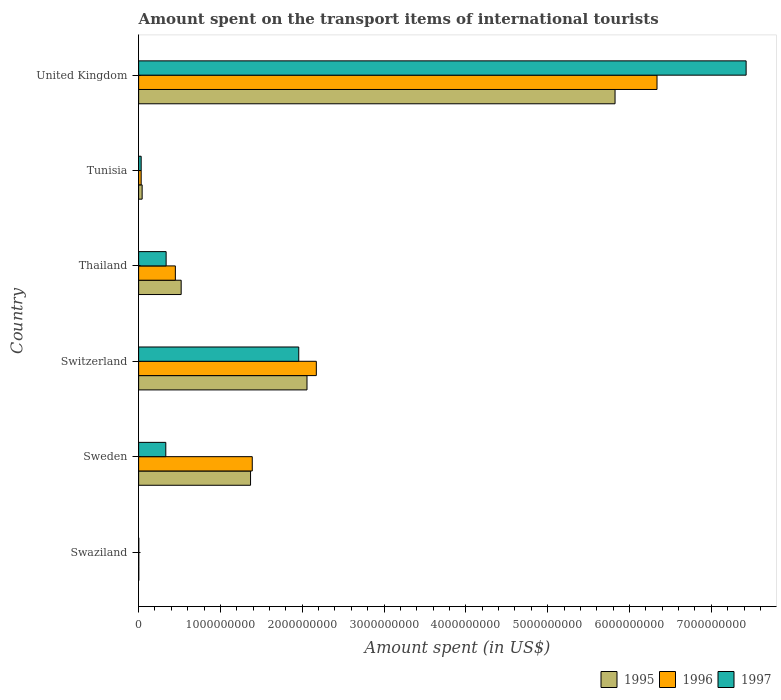How many groups of bars are there?
Give a very brief answer. 6. Are the number of bars per tick equal to the number of legend labels?
Your response must be concise. Yes. In how many cases, is the number of bars for a given country not equal to the number of legend labels?
Provide a succinct answer. 0. What is the amount spent on the transport items of international tourists in 1997 in Sweden?
Make the answer very short. 3.32e+08. Across all countries, what is the maximum amount spent on the transport items of international tourists in 1995?
Your answer should be very brief. 5.82e+09. Across all countries, what is the minimum amount spent on the transport items of international tourists in 1996?
Make the answer very short. 2.00e+06. In which country was the amount spent on the transport items of international tourists in 1996 minimum?
Make the answer very short. Swaziland. What is the total amount spent on the transport items of international tourists in 1996 in the graph?
Ensure brevity in your answer.  1.04e+1. What is the difference between the amount spent on the transport items of international tourists in 1995 in Tunisia and that in United Kingdom?
Provide a succinct answer. -5.78e+09. What is the difference between the amount spent on the transport items of international tourists in 1995 in Switzerland and the amount spent on the transport items of international tourists in 1997 in Swaziland?
Your answer should be compact. 2.06e+09. What is the average amount spent on the transport items of international tourists in 1996 per country?
Make the answer very short. 1.73e+09. What is the difference between the amount spent on the transport items of international tourists in 1996 and amount spent on the transport items of international tourists in 1995 in Sweden?
Give a very brief answer. 2.10e+07. What is the ratio of the amount spent on the transport items of international tourists in 1996 in Switzerland to that in Thailand?
Your answer should be compact. 4.84. Is the amount spent on the transport items of international tourists in 1997 in Sweden less than that in Tunisia?
Give a very brief answer. No. Is the difference between the amount spent on the transport items of international tourists in 1996 in Thailand and United Kingdom greater than the difference between the amount spent on the transport items of international tourists in 1995 in Thailand and United Kingdom?
Your response must be concise. No. What is the difference between the highest and the second highest amount spent on the transport items of international tourists in 1996?
Ensure brevity in your answer.  4.16e+09. What is the difference between the highest and the lowest amount spent on the transport items of international tourists in 1997?
Give a very brief answer. 7.42e+09. What does the 2nd bar from the bottom in United Kingdom represents?
Give a very brief answer. 1996. What is the difference between two consecutive major ticks on the X-axis?
Provide a short and direct response. 1.00e+09. Does the graph contain grids?
Make the answer very short. No. How many legend labels are there?
Offer a terse response. 3. What is the title of the graph?
Your answer should be very brief. Amount spent on the transport items of international tourists. What is the label or title of the X-axis?
Ensure brevity in your answer.  Amount spent (in US$). What is the label or title of the Y-axis?
Provide a succinct answer. Country. What is the Amount spent (in US$) of 1995 in Swaziland?
Provide a succinct answer. 2.00e+06. What is the Amount spent (in US$) in 1996 in Swaziland?
Provide a succinct answer. 2.00e+06. What is the Amount spent (in US$) of 1995 in Sweden?
Provide a succinct answer. 1.37e+09. What is the Amount spent (in US$) in 1996 in Sweden?
Ensure brevity in your answer.  1.39e+09. What is the Amount spent (in US$) in 1997 in Sweden?
Your response must be concise. 3.32e+08. What is the Amount spent (in US$) in 1995 in Switzerland?
Your answer should be very brief. 2.06e+09. What is the Amount spent (in US$) of 1996 in Switzerland?
Give a very brief answer. 2.17e+09. What is the Amount spent (in US$) in 1997 in Switzerland?
Keep it short and to the point. 1.96e+09. What is the Amount spent (in US$) in 1995 in Thailand?
Provide a succinct answer. 5.20e+08. What is the Amount spent (in US$) of 1996 in Thailand?
Ensure brevity in your answer.  4.49e+08. What is the Amount spent (in US$) in 1997 in Thailand?
Your answer should be very brief. 3.36e+08. What is the Amount spent (in US$) in 1995 in Tunisia?
Provide a succinct answer. 4.30e+07. What is the Amount spent (in US$) in 1996 in Tunisia?
Ensure brevity in your answer.  3.10e+07. What is the Amount spent (in US$) in 1997 in Tunisia?
Provide a short and direct response. 3.10e+07. What is the Amount spent (in US$) in 1995 in United Kingdom?
Offer a terse response. 5.82e+09. What is the Amount spent (in US$) in 1996 in United Kingdom?
Ensure brevity in your answer.  6.34e+09. What is the Amount spent (in US$) of 1997 in United Kingdom?
Keep it short and to the point. 7.42e+09. Across all countries, what is the maximum Amount spent (in US$) of 1995?
Your response must be concise. 5.82e+09. Across all countries, what is the maximum Amount spent (in US$) of 1996?
Make the answer very short. 6.34e+09. Across all countries, what is the maximum Amount spent (in US$) in 1997?
Your answer should be compact. 7.42e+09. Across all countries, what is the minimum Amount spent (in US$) in 1997?
Make the answer very short. 2.00e+06. What is the total Amount spent (in US$) of 1995 in the graph?
Offer a very short reply. 9.81e+09. What is the total Amount spent (in US$) in 1996 in the graph?
Offer a very short reply. 1.04e+1. What is the total Amount spent (in US$) of 1997 in the graph?
Provide a succinct answer. 1.01e+1. What is the difference between the Amount spent (in US$) in 1995 in Swaziland and that in Sweden?
Keep it short and to the point. -1.37e+09. What is the difference between the Amount spent (in US$) in 1996 in Swaziland and that in Sweden?
Offer a very short reply. -1.39e+09. What is the difference between the Amount spent (in US$) of 1997 in Swaziland and that in Sweden?
Your answer should be compact. -3.30e+08. What is the difference between the Amount spent (in US$) in 1995 in Swaziland and that in Switzerland?
Your response must be concise. -2.06e+09. What is the difference between the Amount spent (in US$) in 1996 in Swaziland and that in Switzerland?
Provide a succinct answer. -2.17e+09. What is the difference between the Amount spent (in US$) in 1997 in Swaziland and that in Switzerland?
Provide a succinct answer. -1.96e+09. What is the difference between the Amount spent (in US$) of 1995 in Swaziland and that in Thailand?
Make the answer very short. -5.18e+08. What is the difference between the Amount spent (in US$) of 1996 in Swaziland and that in Thailand?
Offer a terse response. -4.47e+08. What is the difference between the Amount spent (in US$) in 1997 in Swaziland and that in Thailand?
Give a very brief answer. -3.34e+08. What is the difference between the Amount spent (in US$) of 1995 in Swaziland and that in Tunisia?
Give a very brief answer. -4.10e+07. What is the difference between the Amount spent (in US$) of 1996 in Swaziland and that in Tunisia?
Give a very brief answer. -2.90e+07. What is the difference between the Amount spent (in US$) in 1997 in Swaziland and that in Tunisia?
Provide a short and direct response. -2.90e+07. What is the difference between the Amount spent (in US$) in 1995 in Swaziland and that in United Kingdom?
Your answer should be very brief. -5.82e+09. What is the difference between the Amount spent (in US$) of 1996 in Swaziland and that in United Kingdom?
Your answer should be compact. -6.33e+09. What is the difference between the Amount spent (in US$) of 1997 in Swaziland and that in United Kingdom?
Your answer should be very brief. -7.42e+09. What is the difference between the Amount spent (in US$) in 1995 in Sweden and that in Switzerland?
Offer a very short reply. -6.90e+08. What is the difference between the Amount spent (in US$) of 1996 in Sweden and that in Switzerland?
Offer a terse response. -7.83e+08. What is the difference between the Amount spent (in US$) of 1997 in Sweden and that in Switzerland?
Offer a terse response. -1.62e+09. What is the difference between the Amount spent (in US$) of 1995 in Sweden and that in Thailand?
Your answer should be compact. 8.48e+08. What is the difference between the Amount spent (in US$) in 1996 in Sweden and that in Thailand?
Your response must be concise. 9.40e+08. What is the difference between the Amount spent (in US$) in 1997 in Sweden and that in Thailand?
Provide a short and direct response. -4.00e+06. What is the difference between the Amount spent (in US$) of 1995 in Sweden and that in Tunisia?
Provide a succinct answer. 1.32e+09. What is the difference between the Amount spent (in US$) of 1996 in Sweden and that in Tunisia?
Offer a terse response. 1.36e+09. What is the difference between the Amount spent (in US$) in 1997 in Sweden and that in Tunisia?
Offer a very short reply. 3.01e+08. What is the difference between the Amount spent (in US$) of 1995 in Sweden and that in United Kingdom?
Offer a very short reply. -4.46e+09. What is the difference between the Amount spent (in US$) in 1996 in Sweden and that in United Kingdom?
Your answer should be very brief. -4.95e+09. What is the difference between the Amount spent (in US$) in 1997 in Sweden and that in United Kingdom?
Make the answer very short. -7.09e+09. What is the difference between the Amount spent (in US$) of 1995 in Switzerland and that in Thailand?
Provide a succinct answer. 1.54e+09. What is the difference between the Amount spent (in US$) in 1996 in Switzerland and that in Thailand?
Your answer should be very brief. 1.72e+09. What is the difference between the Amount spent (in US$) of 1997 in Switzerland and that in Thailand?
Your response must be concise. 1.62e+09. What is the difference between the Amount spent (in US$) of 1995 in Switzerland and that in Tunisia?
Offer a terse response. 2.02e+09. What is the difference between the Amount spent (in US$) of 1996 in Switzerland and that in Tunisia?
Your answer should be compact. 2.14e+09. What is the difference between the Amount spent (in US$) in 1997 in Switzerland and that in Tunisia?
Make the answer very short. 1.93e+09. What is the difference between the Amount spent (in US$) in 1995 in Switzerland and that in United Kingdom?
Provide a succinct answer. -3.76e+09. What is the difference between the Amount spent (in US$) in 1996 in Switzerland and that in United Kingdom?
Your answer should be very brief. -4.16e+09. What is the difference between the Amount spent (in US$) in 1997 in Switzerland and that in United Kingdom?
Ensure brevity in your answer.  -5.47e+09. What is the difference between the Amount spent (in US$) in 1995 in Thailand and that in Tunisia?
Give a very brief answer. 4.77e+08. What is the difference between the Amount spent (in US$) in 1996 in Thailand and that in Tunisia?
Offer a very short reply. 4.18e+08. What is the difference between the Amount spent (in US$) of 1997 in Thailand and that in Tunisia?
Offer a terse response. 3.05e+08. What is the difference between the Amount spent (in US$) of 1995 in Thailand and that in United Kingdom?
Make the answer very short. -5.30e+09. What is the difference between the Amount spent (in US$) in 1996 in Thailand and that in United Kingdom?
Offer a very short reply. -5.89e+09. What is the difference between the Amount spent (in US$) in 1997 in Thailand and that in United Kingdom?
Your answer should be compact. -7.09e+09. What is the difference between the Amount spent (in US$) in 1995 in Tunisia and that in United Kingdom?
Your answer should be very brief. -5.78e+09. What is the difference between the Amount spent (in US$) in 1996 in Tunisia and that in United Kingdom?
Your response must be concise. -6.30e+09. What is the difference between the Amount spent (in US$) of 1997 in Tunisia and that in United Kingdom?
Offer a very short reply. -7.39e+09. What is the difference between the Amount spent (in US$) in 1995 in Swaziland and the Amount spent (in US$) in 1996 in Sweden?
Offer a terse response. -1.39e+09. What is the difference between the Amount spent (in US$) of 1995 in Swaziland and the Amount spent (in US$) of 1997 in Sweden?
Your response must be concise. -3.30e+08. What is the difference between the Amount spent (in US$) in 1996 in Swaziland and the Amount spent (in US$) in 1997 in Sweden?
Offer a very short reply. -3.30e+08. What is the difference between the Amount spent (in US$) in 1995 in Swaziland and the Amount spent (in US$) in 1996 in Switzerland?
Your answer should be compact. -2.17e+09. What is the difference between the Amount spent (in US$) of 1995 in Swaziland and the Amount spent (in US$) of 1997 in Switzerland?
Give a very brief answer. -1.96e+09. What is the difference between the Amount spent (in US$) in 1996 in Swaziland and the Amount spent (in US$) in 1997 in Switzerland?
Provide a short and direct response. -1.96e+09. What is the difference between the Amount spent (in US$) in 1995 in Swaziland and the Amount spent (in US$) in 1996 in Thailand?
Make the answer very short. -4.47e+08. What is the difference between the Amount spent (in US$) of 1995 in Swaziland and the Amount spent (in US$) of 1997 in Thailand?
Your answer should be compact. -3.34e+08. What is the difference between the Amount spent (in US$) in 1996 in Swaziland and the Amount spent (in US$) in 1997 in Thailand?
Your answer should be compact. -3.34e+08. What is the difference between the Amount spent (in US$) in 1995 in Swaziland and the Amount spent (in US$) in 1996 in Tunisia?
Your answer should be compact. -2.90e+07. What is the difference between the Amount spent (in US$) in 1995 in Swaziland and the Amount spent (in US$) in 1997 in Tunisia?
Keep it short and to the point. -2.90e+07. What is the difference between the Amount spent (in US$) in 1996 in Swaziland and the Amount spent (in US$) in 1997 in Tunisia?
Ensure brevity in your answer.  -2.90e+07. What is the difference between the Amount spent (in US$) in 1995 in Swaziland and the Amount spent (in US$) in 1996 in United Kingdom?
Ensure brevity in your answer.  -6.33e+09. What is the difference between the Amount spent (in US$) in 1995 in Swaziland and the Amount spent (in US$) in 1997 in United Kingdom?
Keep it short and to the point. -7.42e+09. What is the difference between the Amount spent (in US$) of 1996 in Swaziland and the Amount spent (in US$) of 1997 in United Kingdom?
Your response must be concise. -7.42e+09. What is the difference between the Amount spent (in US$) of 1995 in Sweden and the Amount spent (in US$) of 1996 in Switzerland?
Ensure brevity in your answer.  -8.04e+08. What is the difference between the Amount spent (in US$) of 1995 in Sweden and the Amount spent (in US$) of 1997 in Switzerland?
Ensure brevity in your answer.  -5.89e+08. What is the difference between the Amount spent (in US$) in 1996 in Sweden and the Amount spent (in US$) in 1997 in Switzerland?
Make the answer very short. -5.68e+08. What is the difference between the Amount spent (in US$) of 1995 in Sweden and the Amount spent (in US$) of 1996 in Thailand?
Make the answer very short. 9.19e+08. What is the difference between the Amount spent (in US$) of 1995 in Sweden and the Amount spent (in US$) of 1997 in Thailand?
Make the answer very short. 1.03e+09. What is the difference between the Amount spent (in US$) in 1996 in Sweden and the Amount spent (in US$) in 1997 in Thailand?
Offer a terse response. 1.05e+09. What is the difference between the Amount spent (in US$) in 1995 in Sweden and the Amount spent (in US$) in 1996 in Tunisia?
Keep it short and to the point. 1.34e+09. What is the difference between the Amount spent (in US$) in 1995 in Sweden and the Amount spent (in US$) in 1997 in Tunisia?
Provide a succinct answer. 1.34e+09. What is the difference between the Amount spent (in US$) in 1996 in Sweden and the Amount spent (in US$) in 1997 in Tunisia?
Offer a very short reply. 1.36e+09. What is the difference between the Amount spent (in US$) of 1995 in Sweden and the Amount spent (in US$) of 1996 in United Kingdom?
Your answer should be very brief. -4.97e+09. What is the difference between the Amount spent (in US$) of 1995 in Sweden and the Amount spent (in US$) of 1997 in United Kingdom?
Provide a short and direct response. -6.06e+09. What is the difference between the Amount spent (in US$) in 1996 in Sweden and the Amount spent (in US$) in 1997 in United Kingdom?
Offer a terse response. -6.04e+09. What is the difference between the Amount spent (in US$) of 1995 in Switzerland and the Amount spent (in US$) of 1996 in Thailand?
Ensure brevity in your answer.  1.61e+09. What is the difference between the Amount spent (in US$) of 1995 in Switzerland and the Amount spent (in US$) of 1997 in Thailand?
Make the answer very short. 1.72e+09. What is the difference between the Amount spent (in US$) in 1996 in Switzerland and the Amount spent (in US$) in 1997 in Thailand?
Your answer should be compact. 1.84e+09. What is the difference between the Amount spent (in US$) in 1995 in Switzerland and the Amount spent (in US$) in 1996 in Tunisia?
Give a very brief answer. 2.03e+09. What is the difference between the Amount spent (in US$) in 1995 in Switzerland and the Amount spent (in US$) in 1997 in Tunisia?
Offer a terse response. 2.03e+09. What is the difference between the Amount spent (in US$) in 1996 in Switzerland and the Amount spent (in US$) in 1997 in Tunisia?
Make the answer very short. 2.14e+09. What is the difference between the Amount spent (in US$) of 1995 in Switzerland and the Amount spent (in US$) of 1996 in United Kingdom?
Your response must be concise. -4.28e+09. What is the difference between the Amount spent (in US$) of 1995 in Switzerland and the Amount spent (in US$) of 1997 in United Kingdom?
Make the answer very short. -5.37e+09. What is the difference between the Amount spent (in US$) in 1996 in Switzerland and the Amount spent (in US$) in 1997 in United Kingdom?
Your answer should be compact. -5.25e+09. What is the difference between the Amount spent (in US$) in 1995 in Thailand and the Amount spent (in US$) in 1996 in Tunisia?
Keep it short and to the point. 4.89e+08. What is the difference between the Amount spent (in US$) of 1995 in Thailand and the Amount spent (in US$) of 1997 in Tunisia?
Provide a succinct answer. 4.89e+08. What is the difference between the Amount spent (in US$) in 1996 in Thailand and the Amount spent (in US$) in 1997 in Tunisia?
Offer a terse response. 4.18e+08. What is the difference between the Amount spent (in US$) of 1995 in Thailand and the Amount spent (in US$) of 1996 in United Kingdom?
Your answer should be very brief. -5.82e+09. What is the difference between the Amount spent (in US$) of 1995 in Thailand and the Amount spent (in US$) of 1997 in United Kingdom?
Ensure brevity in your answer.  -6.90e+09. What is the difference between the Amount spent (in US$) in 1996 in Thailand and the Amount spent (in US$) in 1997 in United Kingdom?
Ensure brevity in your answer.  -6.98e+09. What is the difference between the Amount spent (in US$) in 1995 in Tunisia and the Amount spent (in US$) in 1996 in United Kingdom?
Your answer should be very brief. -6.29e+09. What is the difference between the Amount spent (in US$) in 1995 in Tunisia and the Amount spent (in US$) in 1997 in United Kingdom?
Keep it short and to the point. -7.38e+09. What is the difference between the Amount spent (in US$) in 1996 in Tunisia and the Amount spent (in US$) in 1997 in United Kingdom?
Provide a short and direct response. -7.39e+09. What is the average Amount spent (in US$) in 1995 per country?
Provide a succinct answer. 1.64e+09. What is the average Amount spent (in US$) in 1996 per country?
Give a very brief answer. 1.73e+09. What is the average Amount spent (in US$) of 1997 per country?
Provide a succinct answer. 1.68e+09. What is the difference between the Amount spent (in US$) of 1995 and Amount spent (in US$) of 1996 in Sweden?
Your answer should be very brief. -2.10e+07. What is the difference between the Amount spent (in US$) in 1995 and Amount spent (in US$) in 1997 in Sweden?
Give a very brief answer. 1.04e+09. What is the difference between the Amount spent (in US$) in 1996 and Amount spent (in US$) in 1997 in Sweden?
Give a very brief answer. 1.06e+09. What is the difference between the Amount spent (in US$) of 1995 and Amount spent (in US$) of 1996 in Switzerland?
Give a very brief answer. -1.14e+08. What is the difference between the Amount spent (in US$) in 1995 and Amount spent (in US$) in 1997 in Switzerland?
Your response must be concise. 1.01e+08. What is the difference between the Amount spent (in US$) in 1996 and Amount spent (in US$) in 1997 in Switzerland?
Provide a succinct answer. 2.15e+08. What is the difference between the Amount spent (in US$) of 1995 and Amount spent (in US$) of 1996 in Thailand?
Make the answer very short. 7.10e+07. What is the difference between the Amount spent (in US$) in 1995 and Amount spent (in US$) in 1997 in Thailand?
Provide a short and direct response. 1.84e+08. What is the difference between the Amount spent (in US$) in 1996 and Amount spent (in US$) in 1997 in Thailand?
Ensure brevity in your answer.  1.13e+08. What is the difference between the Amount spent (in US$) of 1995 and Amount spent (in US$) of 1997 in Tunisia?
Your answer should be compact. 1.20e+07. What is the difference between the Amount spent (in US$) in 1995 and Amount spent (in US$) in 1996 in United Kingdom?
Provide a short and direct response. -5.13e+08. What is the difference between the Amount spent (in US$) of 1995 and Amount spent (in US$) of 1997 in United Kingdom?
Provide a short and direct response. -1.60e+09. What is the difference between the Amount spent (in US$) of 1996 and Amount spent (in US$) of 1997 in United Kingdom?
Your response must be concise. -1.09e+09. What is the ratio of the Amount spent (in US$) in 1995 in Swaziland to that in Sweden?
Your answer should be compact. 0. What is the ratio of the Amount spent (in US$) in 1996 in Swaziland to that in Sweden?
Make the answer very short. 0. What is the ratio of the Amount spent (in US$) in 1997 in Swaziland to that in Sweden?
Offer a terse response. 0.01. What is the ratio of the Amount spent (in US$) of 1995 in Swaziland to that in Switzerland?
Offer a very short reply. 0. What is the ratio of the Amount spent (in US$) in 1996 in Swaziland to that in Switzerland?
Give a very brief answer. 0. What is the ratio of the Amount spent (in US$) in 1997 in Swaziland to that in Switzerland?
Give a very brief answer. 0. What is the ratio of the Amount spent (in US$) of 1995 in Swaziland to that in Thailand?
Your answer should be very brief. 0. What is the ratio of the Amount spent (in US$) of 1996 in Swaziland to that in Thailand?
Your response must be concise. 0. What is the ratio of the Amount spent (in US$) of 1997 in Swaziland to that in Thailand?
Your answer should be compact. 0.01. What is the ratio of the Amount spent (in US$) of 1995 in Swaziland to that in Tunisia?
Your answer should be very brief. 0.05. What is the ratio of the Amount spent (in US$) of 1996 in Swaziland to that in Tunisia?
Offer a terse response. 0.06. What is the ratio of the Amount spent (in US$) of 1997 in Swaziland to that in Tunisia?
Give a very brief answer. 0.06. What is the ratio of the Amount spent (in US$) in 1995 in Sweden to that in Switzerland?
Keep it short and to the point. 0.66. What is the ratio of the Amount spent (in US$) in 1996 in Sweden to that in Switzerland?
Keep it short and to the point. 0.64. What is the ratio of the Amount spent (in US$) of 1997 in Sweden to that in Switzerland?
Your answer should be compact. 0.17. What is the ratio of the Amount spent (in US$) of 1995 in Sweden to that in Thailand?
Keep it short and to the point. 2.63. What is the ratio of the Amount spent (in US$) in 1996 in Sweden to that in Thailand?
Keep it short and to the point. 3.09. What is the ratio of the Amount spent (in US$) in 1997 in Sweden to that in Thailand?
Keep it short and to the point. 0.99. What is the ratio of the Amount spent (in US$) of 1995 in Sweden to that in Tunisia?
Provide a short and direct response. 31.81. What is the ratio of the Amount spent (in US$) in 1996 in Sweden to that in Tunisia?
Provide a succinct answer. 44.81. What is the ratio of the Amount spent (in US$) of 1997 in Sweden to that in Tunisia?
Offer a terse response. 10.71. What is the ratio of the Amount spent (in US$) in 1995 in Sweden to that in United Kingdom?
Make the answer very short. 0.23. What is the ratio of the Amount spent (in US$) of 1996 in Sweden to that in United Kingdom?
Your response must be concise. 0.22. What is the ratio of the Amount spent (in US$) in 1997 in Sweden to that in United Kingdom?
Keep it short and to the point. 0.04. What is the ratio of the Amount spent (in US$) in 1995 in Switzerland to that in Thailand?
Your answer should be compact. 3.96. What is the ratio of the Amount spent (in US$) of 1996 in Switzerland to that in Thailand?
Provide a succinct answer. 4.84. What is the ratio of the Amount spent (in US$) in 1997 in Switzerland to that in Thailand?
Ensure brevity in your answer.  5.82. What is the ratio of the Amount spent (in US$) in 1995 in Switzerland to that in Tunisia?
Offer a very short reply. 47.86. What is the ratio of the Amount spent (in US$) of 1996 in Switzerland to that in Tunisia?
Keep it short and to the point. 70.06. What is the ratio of the Amount spent (in US$) of 1997 in Switzerland to that in Tunisia?
Offer a terse response. 63.13. What is the ratio of the Amount spent (in US$) of 1995 in Switzerland to that in United Kingdom?
Keep it short and to the point. 0.35. What is the ratio of the Amount spent (in US$) in 1996 in Switzerland to that in United Kingdom?
Your answer should be compact. 0.34. What is the ratio of the Amount spent (in US$) of 1997 in Switzerland to that in United Kingdom?
Make the answer very short. 0.26. What is the ratio of the Amount spent (in US$) of 1995 in Thailand to that in Tunisia?
Ensure brevity in your answer.  12.09. What is the ratio of the Amount spent (in US$) of 1996 in Thailand to that in Tunisia?
Provide a succinct answer. 14.48. What is the ratio of the Amount spent (in US$) in 1997 in Thailand to that in Tunisia?
Keep it short and to the point. 10.84. What is the ratio of the Amount spent (in US$) of 1995 in Thailand to that in United Kingdom?
Provide a succinct answer. 0.09. What is the ratio of the Amount spent (in US$) of 1996 in Thailand to that in United Kingdom?
Give a very brief answer. 0.07. What is the ratio of the Amount spent (in US$) in 1997 in Thailand to that in United Kingdom?
Give a very brief answer. 0.05. What is the ratio of the Amount spent (in US$) of 1995 in Tunisia to that in United Kingdom?
Give a very brief answer. 0.01. What is the ratio of the Amount spent (in US$) in 1996 in Tunisia to that in United Kingdom?
Keep it short and to the point. 0. What is the ratio of the Amount spent (in US$) of 1997 in Tunisia to that in United Kingdom?
Offer a terse response. 0. What is the difference between the highest and the second highest Amount spent (in US$) of 1995?
Make the answer very short. 3.76e+09. What is the difference between the highest and the second highest Amount spent (in US$) in 1996?
Provide a succinct answer. 4.16e+09. What is the difference between the highest and the second highest Amount spent (in US$) of 1997?
Your answer should be compact. 5.47e+09. What is the difference between the highest and the lowest Amount spent (in US$) in 1995?
Your response must be concise. 5.82e+09. What is the difference between the highest and the lowest Amount spent (in US$) of 1996?
Offer a very short reply. 6.33e+09. What is the difference between the highest and the lowest Amount spent (in US$) of 1997?
Provide a succinct answer. 7.42e+09. 